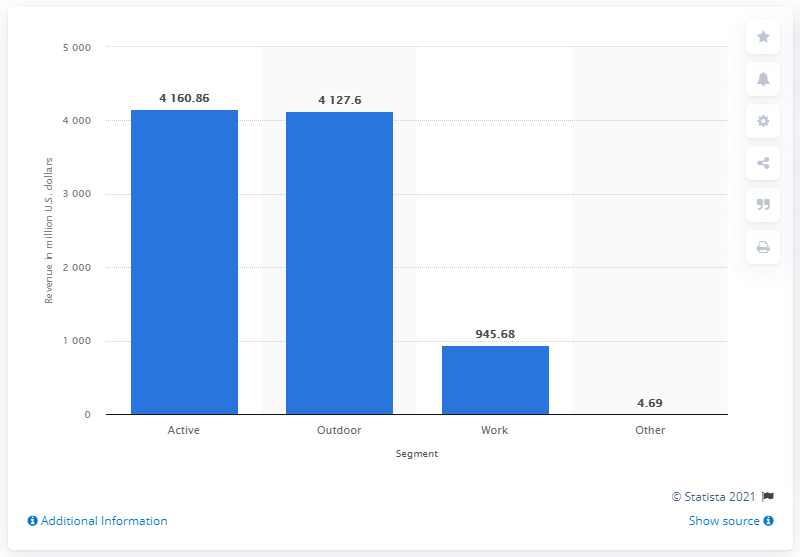Specify some key components in this picture. The VF Corporation's active segment generated global revenue of 4160.86 in the fiscal year 2021. 